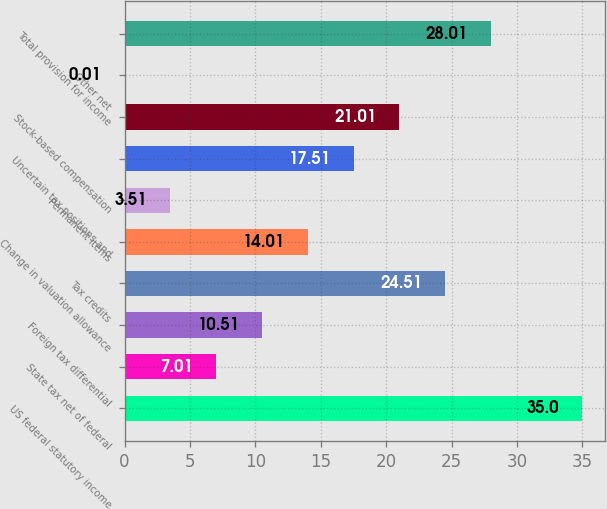<chart> <loc_0><loc_0><loc_500><loc_500><bar_chart><fcel>US federal statutory income<fcel>State tax net of federal<fcel>Foreign tax differential<fcel>Tax credits<fcel>Change in valuation allowance<fcel>Permanent items<fcel>Uncertain tax positions and<fcel>Stock-based compensation<fcel>Other net<fcel>Total provision for income<nl><fcel>35<fcel>7.01<fcel>10.51<fcel>24.51<fcel>14.01<fcel>3.51<fcel>17.51<fcel>21.01<fcel>0.01<fcel>28.01<nl></chart> 